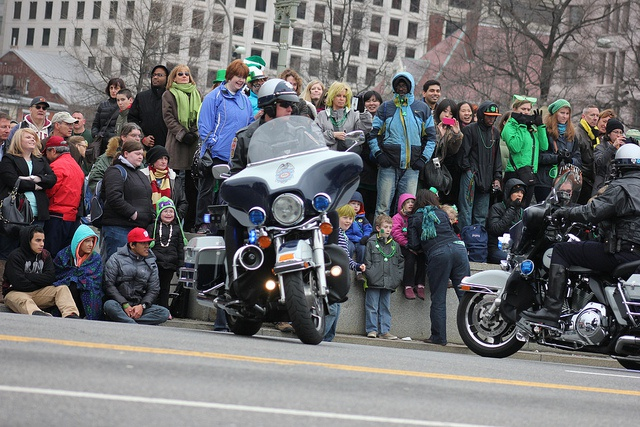Describe the objects in this image and their specific colors. I can see people in gray, black, darkgray, and navy tones, motorcycle in gray, black, darkgray, and lightgray tones, motorcycle in gray, black, darkgray, and lightgray tones, people in gray, black, and lightgray tones, and people in gray, darkgray, black, and lightgray tones in this image. 